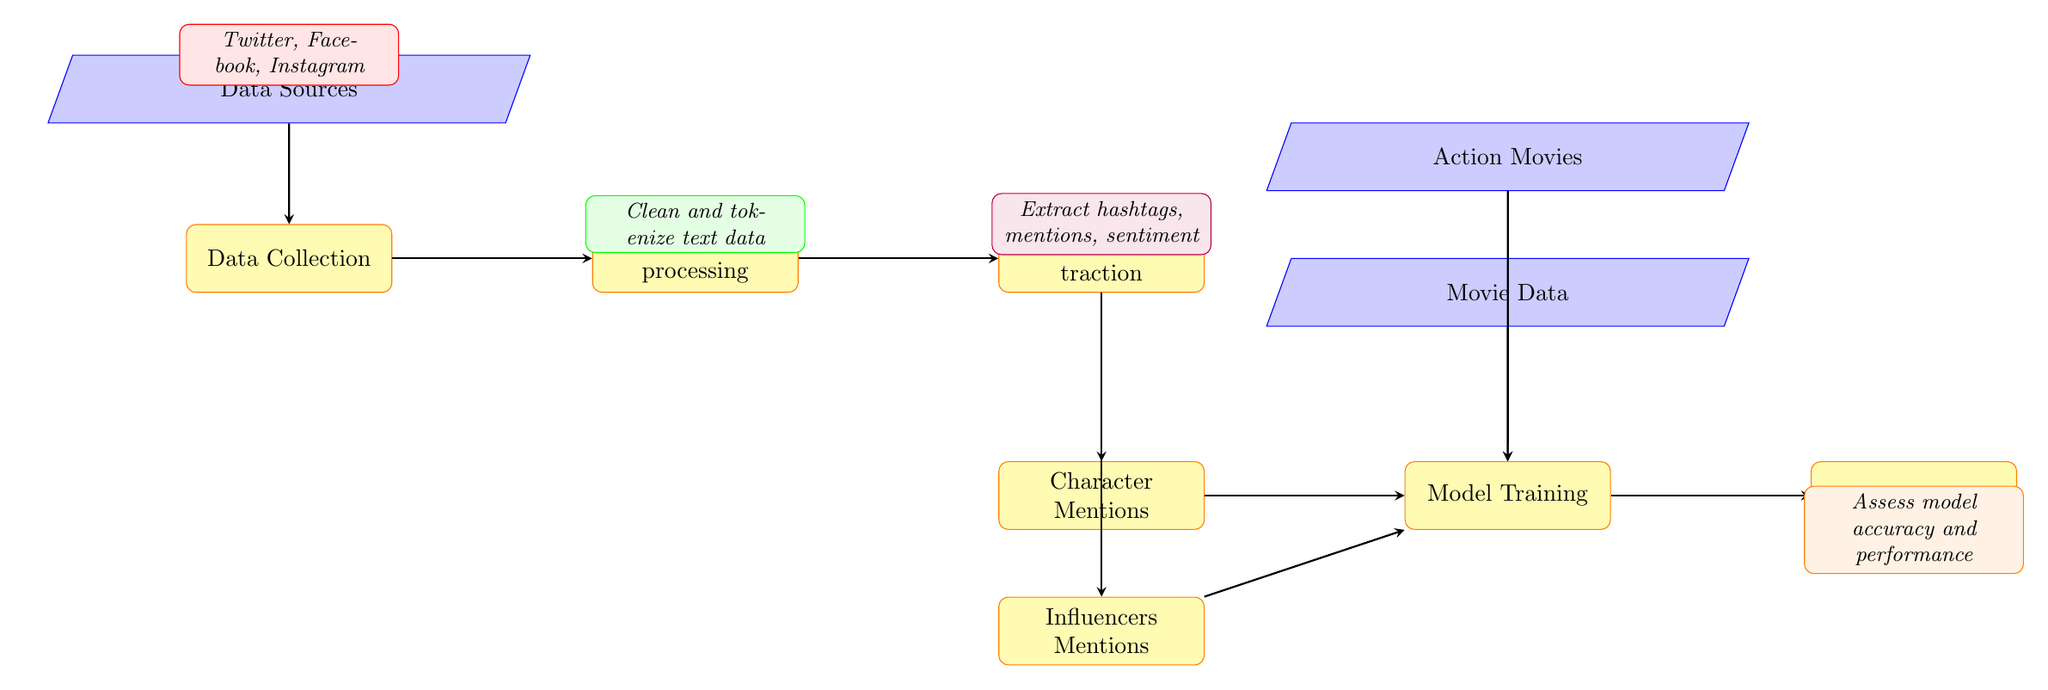What is the first process in the diagram? The first process node in the diagram is labeled "Data Collection," which is positioned at the bottom of the first column and serves as the starting point for the workflow.
Answer: Data Collection How many data sources are outlined in the diagram? The diagram specifies three data sources, which are Twitter, Facebook, and Instagram, listed in the node labeled "Data Sources" above the "Data Collection" process.
Answer: Three What does the "Data Preprocessing" node signify in the workflow? The "Data Preprocessing" node represents the step where text data is cleaned and tokenized, as indicated by the text inside the node, which describes this operation clearly.
Answer: Clean and tokenize text data Which nodes inform the "Model Training" process? The "Model Training" node receives input from four sources: "Character Mentions," "Influencers Mentions," "Movie Data," and "Action Movies," which are represented by arrows leading into the node from its left and above.
Answer: Character Mentions, Influencers Mentions, Movie Data, Action Movies What is the final stage in the diagram? The diagram culminates with the "Model Evaluation" node, positioned at the far right, symbolizing the process where the model's accuracy and performance are assessed after training.
Answer: Model Evaluation What type of data is emphasized in the "Movie Data" node? The "Movie Data" node highlights information specifically related to movies, suggesting that the underlying focus is on data pertinent to films, which is crucial for training the model.
Answer: Movie Data How many processes are indicated in the total workflow? There are five process nodes in the diagram, which are "Data Collection," "Data Preprocessing," "Feature Extraction," "Model Training," and "Model Evaluation," reflecting the various stages of the machine learning pipeline.
Answer: Five What does the "Feature Extraction" process entail? The "Feature Extraction" process focuses on extracting important elements from the data, specifically hashtags, mentions, and sentiment, as stated within the node itself, which guides the subsequent stages.
Answer: Extract hashtags, mentions, sentiment 